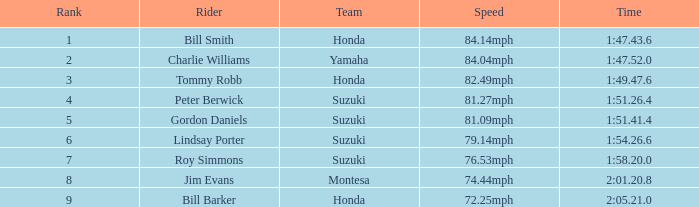Parse the table in full. {'header': ['Rank', 'Rider', 'Team', 'Speed', 'Time'], 'rows': [['1', 'Bill Smith', 'Honda', '84.14mph', '1:47.43.6'], ['2', 'Charlie Williams', 'Yamaha', '84.04mph', '1:47.52.0'], ['3', 'Tommy Robb', 'Honda', '82.49mph', '1:49.47.6'], ['4', 'Peter Berwick', 'Suzuki', '81.27mph', '1:51.26.4'], ['5', 'Gordon Daniels', 'Suzuki', '81.09mph', '1:51.41.4'], ['6', 'Lindsay Porter', 'Suzuki', '79.14mph', '1:54.26.6'], ['7', 'Roy Simmons', 'Suzuki', '76.53mph', '1:58.20.0'], ['8', 'Jim Evans', 'Montesa', '74.44mph', '2:01.20.8'], ['9', 'Bill Barker', 'Honda', '72.25mph', '2:05.21.0']]} 6? Lindsay Porter. 